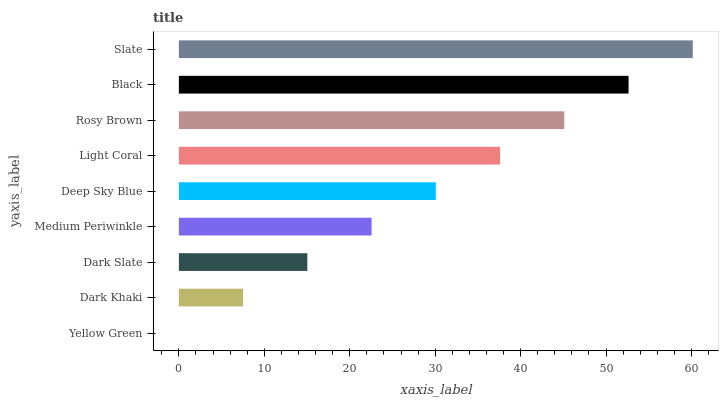Is Yellow Green the minimum?
Answer yes or no. Yes. Is Slate the maximum?
Answer yes or no. Yes. Is Dark Khaki the minimum?
Answer yes or no. No. Is Dark Khaki the maximum?
Answer yes or no. No. Is Dark Khaki greater than Yellow Green?
Answer yes or no. Yes. Is Yellow Green less than Dark Khaki?
Answer yes or no. Yes. Is Yellow Green greater than Dark Khaki?
Answer yes or no. No. Is Dark Khaki less than Yellow Green?
Answer yes or no. No. Is Deep Sky Blue the high median?
Answer yes or no. Yes. Is Deep Sky Blue the low median?
Answer yes or no. Yes. Is Dark Khaki the high median?
Answer yes or no. No. Is Medium Periwinkle the low median?
Answer yes or no. No. 